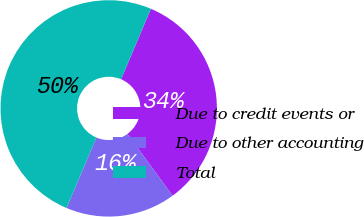Convert chart. <chart><loc_0><loc_0><loc_500><loc_500><pie_chart><fcel>Due to credit events or<fcel>Due to other accounting<fcel>Total<nl><fcel>33.57%<fcel>16.43%<fcel>50.0%<nl></chart> 